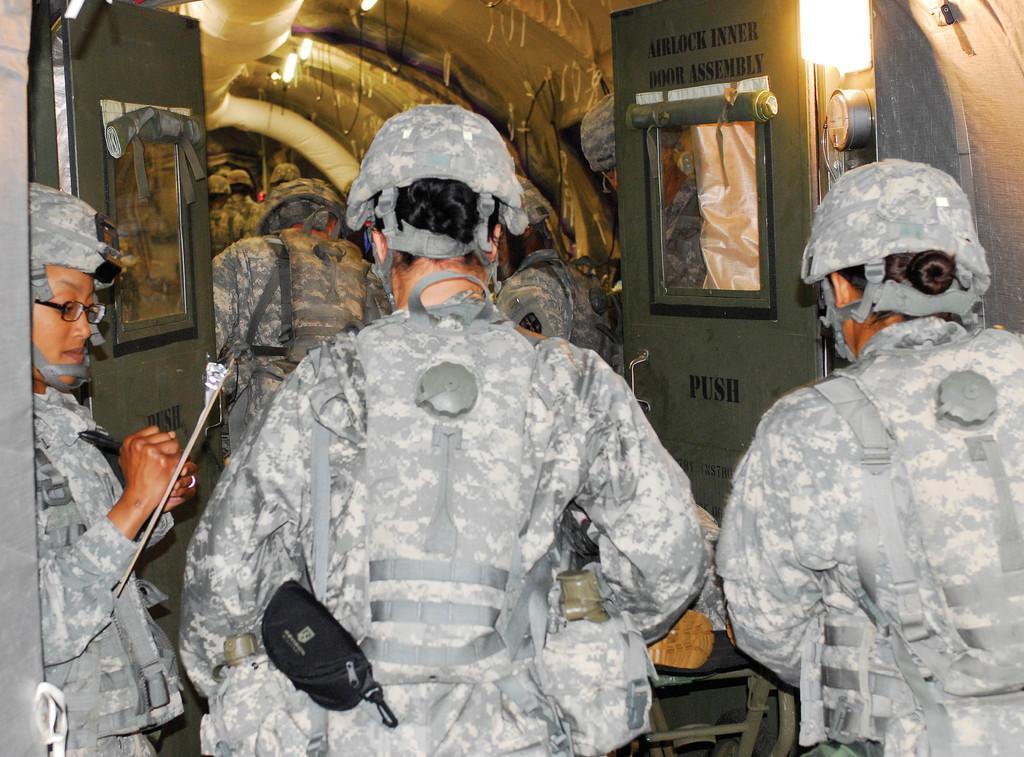Could you give a brief overview of what you see in this image? In the image there are many persons in camouflage dress and helmet walking in to a vehicle. 